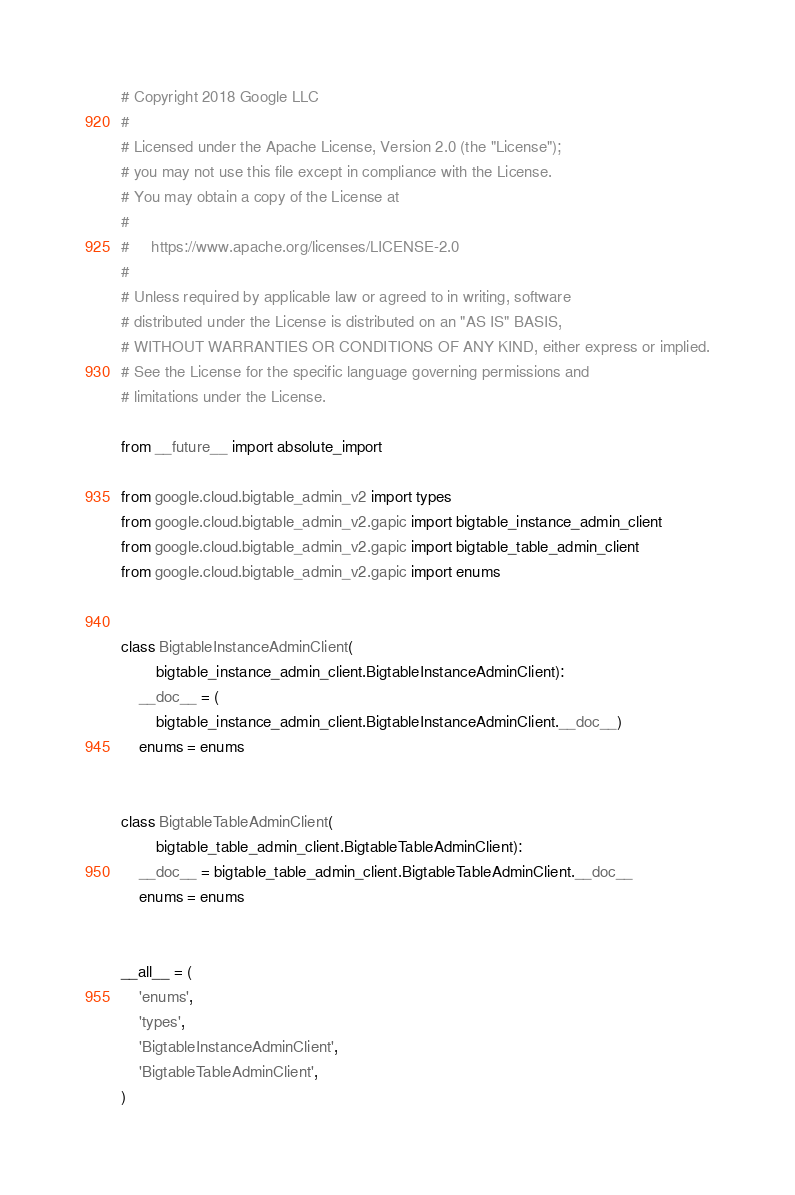Convert code to text. <code><loc_0><loc_0><loc_500><loc_500><_Python_># Copyright 2018 Google LLC
#
# Licensed under the Apache License, Version 2.0 (the "License");
# you may not use this file except in compliance with the License.
# You may obtain a copy of the License at
#
#     https://www.apache.org/licenses/LICENSE-2.0
#
# Unless required by applicable law or agreed to in writing, software
# distributed under the License is distributed on an "AS IS" BASIS,
# WITHOUT WARRANTIES OR CONDITIONS OF ANY KIND, either express or implied.
# See the License for the specific language governing permissions and
# limitations under the License.

from __future__ import absolute_import

from google.cloud.bigtable_admin_v2 import types
from google.cloud.bigtable_admin_v2.gapic import bigtable_instance_admin_client
from google.cloud.bigtable_admin_v2.gapic import bigtable_table_admin_client
from google.cloud.bigtable_admin_v2.gapic import enums


class BigtableInstanceAdminClient(
        bigtable_instance_admin_client.BigtableInstanceAdminClient):
    __doc__ = (
        bigtable_instance_admin_client.BigtableInstanceAdminClient.__doc__)
    enums = enums


class BigtableTableAdminClient(
        bigtable_table_admin_client.BigtableTableAdminClient):
    __doc__ = bigtable_table_admin_client.BigtableTableAdminClient.__doc__
    enums = enums


__all__ = (
    'enums',
    'types',
    'BigtableInstanceAdminClient',
    'BigtableTableAdminClient',
)
</code> 